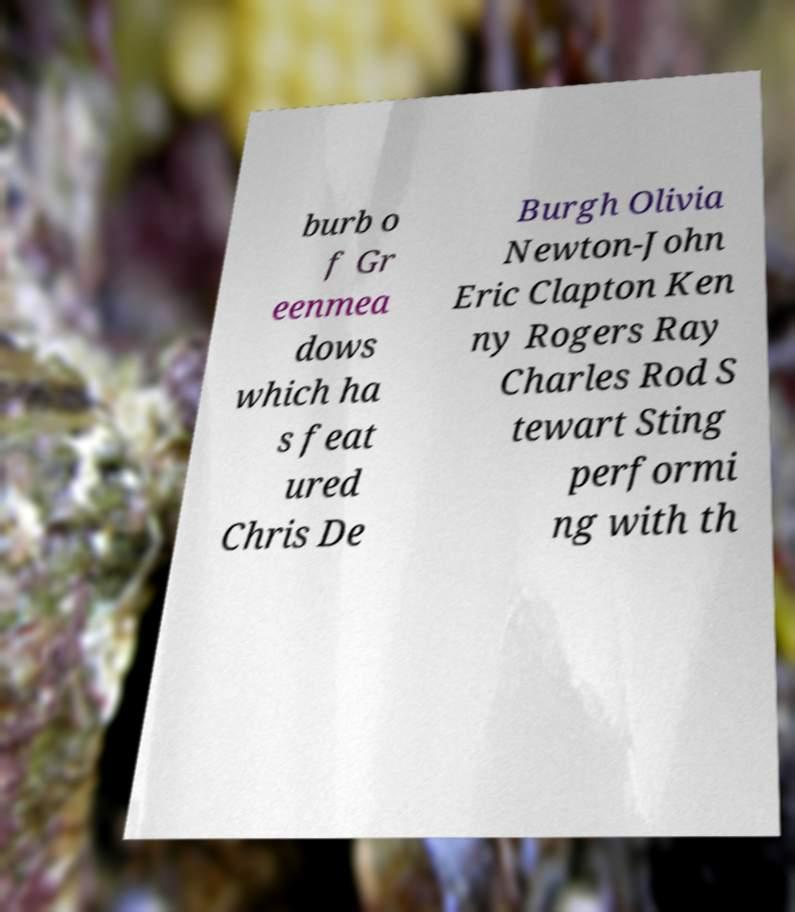Please read and relay the text visible in this image. What does it say? burb o f Gr eenmea dows which ha s feat ured Chris De Burgh Olivia Newton-John Eric Clapton Ken ny Rogers Ray Charles Rod S tewart Sting performi ng with th 